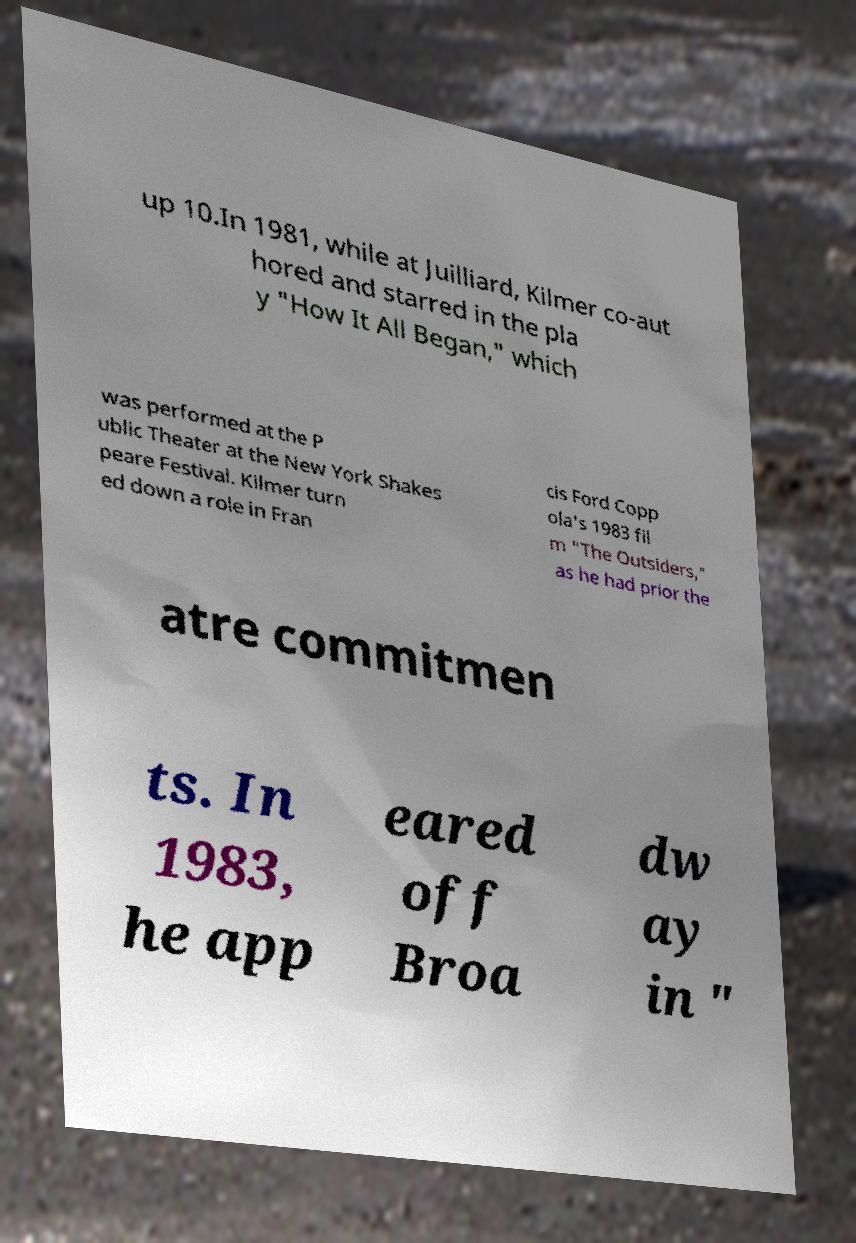Please identify and transcribe the text found in this image. up 10.In 1981, while at Juilliard, Kilmer co-aut hored and starred in the pla y "How It All Began," which was performed at the P ublic Theater at the New York Shakes peare Festival. Kilmer turn ed down a role in Fran cis Ford Copp ola's 1983 fil m "The Outsiders," as he had prior the atre commitmen ts. In 1983, he app eared off Broa dw ay in " 